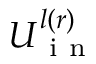<formula> <loc_0><loc_0><loc_500><loc_500>U _ { i n } ^ { l ( r ) }</formula> 